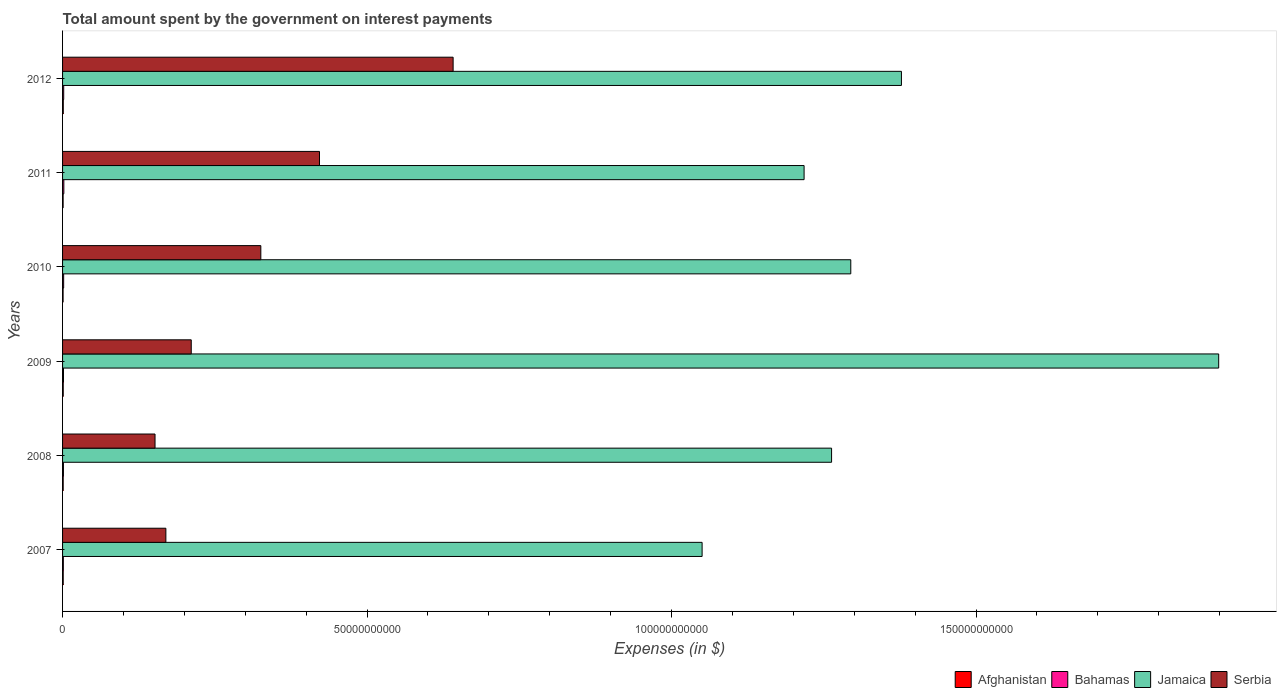How many groups of bars are there?
Make the answer very short. 6. Are the number of bars per tick equal to the number of legend labels?
Make the answer very short. Yes. How many bars are there on the 1st tick from the top?
Provide a short and direct response. 4. What is the label of the 3rd group of bars from the top?
Your response must be concise. 2010. In how many cases, is the number of bars for a given year not equal to the number of legend labels?
Ensure brevity in your answer.  0. What is the amount spent on interest payments by the government in Afghanistan in 2009?
Your answer should be compact. 1.09e+08. Across all years, what is the maximum amount spent on interest payments by the government in Afghanistan?
Your answer should be very brief. 1.18e+08. Across all years, what is the minimum amount spent on interest payments by the government in Serbia?
Your answer should be very brief. 1.52e+1. What is the total amount spent on interest payments by the government in Serbia in the graph?
Your answer should be compact. 1.92e+11. What is the difference between the amount spent on interest payments by the government in Bahamas in 2008 and that in 2009?
Your answer should be compact. -1.11e+07. What is the difference between the amount spent on interest payments by the government in Bahamas in 2011 and the amount spent on interest payments by the government in Afghanistan in 2007?
Offer a very short reply. 1.04e+08. What is the average amount spent on interest payments by the government in Afghanistan per year?
Give a very brief answer. 1.03e+08. In the year 2008, what is the difference between the amount spent on interest payments by the government in Jamaica and amount spent on interest payments by the government in Afghanistan?
Provide a succinct answer. 1.26e+11. What is the ratio of the amount spent on interest payments by the government in Serbia in 2008 to that in 2009?
Provide a short and direct response. 0.72. What is the difference between the highest and the second highest amount spent on interest payments by the government in Afghanistan?
Your answer should be very brief. 9.61e+06. What is the difference between the highest and the lowest amount spent on interest payments by the government in Jamaica?
Make the answer very short. 8.48e+1. What does the 4th bar from the top in 2007 represents?
Ensure brevity in your answer.  Afghanistan. What does the 2nd bar from the bottom in 2012 represents?
Offer a very short reply. Bahamas. Is it the case that in every year, the sum of the amount spent on interest payments by the government in Bahamas and amount spent on interest payments by the government in Serbia is greater than the amount spent on interest payments by the government in Afghanistan?
Keep it short and to the point. Yes. How many bars are there?
Ensure brevity in your answer.  24. Are all the bars in the graph horizontal?
Your response must be concise. Yes. What is the difference between two consecutive major ticks on the X-axis?
Make the answer very short. 5.00e+1. Are the values on the major ticks of X-axis written in scientific E-notation?
Your answer should be very brief. No. Does the graph contain any zero values?
Keep it short and to the point. No. Does the graph contain grids?
Keep it short and to the point. No. Where does the legend appear in the graph?
Keep it short and to the point. Bottom right. How are the legend labels stacked?
Offer a very short reply. Horizontal. What is the title of the graph?
Provide a short and direct response. Total amount spent by the government on interest payments. Does "Jordan" appear as one of the legend labels in the graph?
Provide a short and direct response. No. What is the label or title of the X-axis?
Provide a short and direct response. Expenses (in $). What is the label or title of the Y-axis?
Offer a terse response. Years. What is the Expenses (in $) in Afghanistan in 2007?
Your answer should be very brief. 1.07e+08. What is the Expenses (in $) in Bahamas in 2007?
Offer a very short reply. 1.27e+08. What is the Expenses (in $) in Jamaica in 2007?
Your answer should be compact. 1.05e+11. What is the Expenses (in $) of Serbia in 2007?
Offer a very short reply. 1.70e+1. What is the Expenses (in $) in Afghanistan in 2008?
Offer a very short reply. 1.03e+08. What is the Expenses (in $) of Bahamas in 2008?
Your answer should be compact. 1.43e+08. What is the Expenses (in $) of Jamaica in 2008?
Keep it short and to the point. 1.26e+11. What is the Expenses (in $) of Serbia in 2008?
Ensure brevity in your answer.  1.52e+1. What is the Expenses (in $) of Afghanistan in 2009?
Give a very brief answer. 1.09e+08. What is the Expenses (in $) of Bahamas in 2009?
Your answer should be very brief. 1.54e+08. What is the Expenses (in $) in Jamaica in 2009?
Your answer should be very brief. 1.90e+11. What is the Expenses (in $) of Serbia in 2009?
Ensure brevity in your answer.  2.11e+1. What is the Expenses (in $) in Afghanistan in 2010?
Ensure brevity in your answer.  8.66e+07. What is the Expenses (in $) of Bahamas in 2010?
Keep it short and to the point. 1.78e+08. What is the Expenses (in $) of Jamaica in 2010?
Keep it short and to the point. 1.29e+11. What is the Expenses (in $) in Serbia in 2010?
Your answer should be very brief. 3.26e+1. What is the Expenses (in $) in Afghanistan in 2011?
Provide a short and direct response. 9.20e+07. What is the Expenses (in $) in Bahamas in 2011?
Make the answer very short. 2.11e+08. What is the Expenses (in $) of Jamaica in 2011?
Provide a short and direct response. 1.22e+11. What is the Expenses (in $) of Serbia in 2011?
Provide a succinct answer. 4.22e+1. What is the Expenses (in $) in Afghanistan in 2012?
Ensure brevity in your answer.  1.18e+08. What is the Expenses (in $) in Bahamas in 2012?
Give a very brief answer. 1.86e+08. What is the Expenses (in $) of Jamaica in 2012?
Provide a succinct answer. 1.38e+11. What is the Expenses (in $) of Serbia in 2012?
Provide a short and direct response. 6.41e+1. Across all years, what is the maximum Expenses (in $) of Afghanistan?
Give a very brief answer. 1.18e+08. Across all years, what is the maximum Expenses (in $) in Bahamas?
Make the answer very short. 2.11e+08. Across all years, what is the maximum Expenses (in $) in Jamaica?
Offer a terse response. 1.90e+11. Across all years, what is the maximum Expenses (in $) of Serbia?
Ensure brevity in your answer.  6.41e+1. Across all years, what is the minimum Expenses (in $) of Afghanistan?
Provide a short and direct response. 8.66e+07. Across all years, what is the minimum Expenses (in $) in Bahamas?
Offer a very short reply. 1.27e+08. Across all years, what is the minimum Expenses (in $) of Jamaica?
Your response must be concise. 1.05e+11. Across all years, what is the minimum Expenses (in $) in Serbia?
Provide a short and direct response. 1.52e+1. What is the total Expenses (in $) of Afghanistan in the graph?
Offer a terse response. 6.15e+08. What is the total Expenses (in $) of Bahamas in the graph?
Ensure brevity in your answer.  1.00e+09. What is the total Expenses (in $) of Jamaica in the graph?
Your response must be concise. 8.10e+11. What is the total Expenses (in $) of Serbia in the graph?
Offer a very short reply. 1.92e+11. What is the difference between the Expenses (in $) of Afghanistan in 2007 and that in 2008?
Your answer should be compact. 3.63e+06. What is the difference between the Expenses (in $) of Bahamas in 2007 and that in 2008?
Offer a terse response. -1.60e+07. What is the difference between the Expenses (in $) in Jamaica in 2007 and that in 2008?
Your response must be concise. -2.13e+1. What is the difference between the Expenses (in $) in Serbia in 2007 and that in 2008?
Keep it short and to the point. 1.78e+09. What is the difference between the Expenses (in $) of Afghanistan in 2007 and that in 2009?
Your response must be concise. -1.90e+06. What is the difference between the Expenses (in $) of Bahamas in 2007 and that in 2009?
Your response must be concise. -2.71e+07. What is the difference between the Expenses (in $) of Jamaica in 2007 and that in 2009?
Provide a succinct answer. -8.48e+1. What is the difference between the Expenses (in $) in Serbia in 2007 and that in 2009?
Your response must be concise. -4.17e+09. What is the difference between the Expenses (in $) of Afghanistan in 2007 and that in 2010?
Offer a very short reply. 2.01e+07. What is the difference between the Expenses (in $) of Bahamas in 2007 and that in 2010?
Offer a very short reply. -5.13e+07. What is the difference between the Expenses (in $) of Jamaica in 2007 and that in 2010?
Offer a terse response. -2.44e+1. What is the difference between the Expenses (in $) of Serbia in 2007 and that in 2010?
Provide a short and direct response. -1.56e+1. What is the difference between the Expenses (in $) in Afghanistan in 2007 and that in 2011?
Provide a short and direct response. 1.47e+07. What is the difference between the Expenses (in $) in Bahamas in 2007 and that in 2011?
Your answer should be compact. -8.36e+07. What is the difference between the Expenses (in $) in Jamaica in 2007 and that in 2011?
Offer a very short reply. -1.67e+1. What is the difference between the Expenses (in $) of Serbia in 2007 and that in 2011?
Make the answer very short. -2.52e+1. What is the difference between the Expenses (in $) in Afghanistan in 2007 and that in 2012?
Make the answer very short. -1.15e+07. What is the difference between the Expenses (in $) in Bahamas in 2007 and that in 2012?
Provide a short and direct response. -5.89e+07. What is the difference between the Expenses (in $) of Jamaica in 2007 and that in 2012?
Your answer should be very brief. -3.27e+1. What is the difference between the Expenses (in $) in Serbia in 2007 and that in 2012?
Make the answer very short. -4.72e+1. What is the difference between the Expenses (in $) of Afghanistan in 2008 and that in 2009?
Provide a succinct answer. -5.54e+06. What is the difference between the Expenses (in $) in Bahamas in 2008 and that in 2009?
Make the answer very short. -1.11e+07. What is the difference between the Expenses (in $) in Jamaica in 2008 and that in 2009?
Your answer should be compact. -6.36e+1. What is the difference between the Expenses (in $) in Serbia in 2008 and that in 2009?
Offer a terse response. -5.95e+09. What is the difference between the Expenses (in $) of Afghanistan in 2008 and that in 2010?
Your response must be concise. 1.65e+07. What is the difference between the Expenses (in $) in Bahamas in 2008 and that in 2010?
Your response must be concise. -3.53e+07. What is the difference between the Expenses (in $) in Jamaica in 2008 and that in 2010?
Give a very brief answer. -3.15e+09. What is the difference between the Expenses (in $) of Serbia in 2008 and that in 2010?
Your response must be concise. -1.74e+1. What is the difference between the Expenses (in $) of Afghanistan in 2008 and that in 2011?
Give a very brief answer. 1.11e+07. What is the difference between the Expenses (in $) of Bahamas in 2008 and that in 2011?
Ensure brevity in your answer.  -6.76e+07. What is the difference between the Expenses (in $) of Jamaica in 2008 and that in 2011?
Offer a very short reply. 4.51e+09. What is the difference between the Expenses (in $) in Serbia in 2008 and that in 2011?
Your response must be concise. -2.70e+1. What is the difference between the Expenses (in $) of Afghanistan in 2008 and that in 2012?
Ensure brevity in your answer.  -1.51e+07. What is the difference between the Expenses (in $) in Bahamas in 2008 and that in 2012?
Provide a short and direct response. -4.30e+07. What is the difference between the Expenses (in $) in Jamaica in 2008 and that in 2012?
Your response must be concise. -1.15e+1. What is the difference between the Expenses (in $) of Serbia in 2008 and that in 2012?
Give a very brief answer. -4.89e+1. What is the difference between the Expenses (in $) of Afghanistan in 2009 and that in 2010?
Your answer should be very brief. 2.20e+07. What is the difference between the Expenses (in $) in Bahamas in 2009 and that in 2010?
Provide a succinct answer. -2.42e+07. What is the difference between the Expenses (in $) of Jamaica in 2009 and that in 2010?
Provide a short and direct response. 6.04e+1. What is the difference between the Expenses (in $) of Serbia in 2009 and that in 2010?
Provide a succinct answer. -1.14e+1. What is the difference between the Expenses (in $) in Afghanistan in 2009 and that in 2011?
Provide a succinct answer. 1.66e+07. What is the difference between the Expenses (in $) of Bahamas in 2009 and that in 2011?
Keep it short and to the point. -5.65e+07. What is the difference between the Expenses (in $) in Jamaica in 2009 and that in 2011?
Offer a very short reply. 6.81e+1. What is the difference between the Expenses (in $) in Serbia in 2009 and that in 2011?
Give a very brief answer. -2.11e+1. What is the difference between the Expenses (in $) in Afghanistan in 2009 and that in 2012?
Offer a very short reply. -9.61e+06. What is the difference between the Expenses (in $) in Bahamas in 2009 and that in 2012?
Provide a succinct answer. -3.19e+07. What is the difference between the Expenses (in $) of Jamaica in 2009 and that in 2012?
Give a very brief answer. 5.21e+1. What is the difference between the Expenses (in $) in Serbia in 2009 and that in 2012?
Ensure brevity in your answer.  -4.30e+1. What is the difference between the Expenses (in $) in Afghanistan in 2010 and that in 2011?
Offer a very short reply. -5.34e+06. What is the difference between the Expenses (in $) in Bahamas in 2010 and that in 2011?
Offer a terse response. -3.23e+07. What is the difference between the Expenses (in $) in Jamaica in 2010 and that in 2011?
Provide a succinct answer. 7.67e+09. What is the difference between the Expenses (in $) in Serbia in 2010 and that in 2011?
Provide a short and direct response. -9.63e+09. What is the difference between the Expenses (in $) in Afghanistan in 2010 and that in 2012?
Your answer should be very brief. -3.16e+07. What is the difference between the Expenses (in $) in Bahamas in 2010 and that in 2012?
Provide a succinct answer. -7.64e+06. What is the difference between the Expenses (in $) in Jamaica in 2010 and that in 2012?
Offer a very short reply. -8.32e+09. What is the difference between the Expenses (in $) of Serbia in 2010 and that in 2012?
Your answer should be very brief. -3.16e+1. What is the difference between the Expenses (in $) in Afghanistan in 2011 and that in 2012?
Ensure brevity in your answer.  -2.63e+07. What is the difference between the Expenses (in $) in Bahamas in 2011 and that in 2012?
Ensure brevity in your answer.  2.47e+07. What is the difference between the Expenses (in $) in Jamaica in 2011 and that in 2012?
Your answer should be very brief. -1.60e+1. What is the difference between the Expenses (in $) of Serbia in 2011 and that in 2012?
Provide a short and direct response. -2.19e+1. What is the difference between the Expenses (in $) in Afghanistan in 2007 and the Expenses (in $) in Bahamas in 2008?
Your answer should be compact. -3.64e+07. What is the difference between the Expenses (in $) of Afghanistan in 2007 and the Expenses (in $) of Jamaica in 2008?
Offer a very short reply. -1.26e+11. What is the difference between the Expenses (in $) in Afghanistan in 2007 and the Expenses (in $) in Serbia in 2008?
Ensure brevity in your answer.  -1.51e+1. What is the difference between the Expenses (in $) of Bahamas in 2007 and the Expenses (in $) of Jamaica in 2008?
Your response must be concise. -1.26e+11. What is the difference between the Expenses (in $) in Bahamas in 2007 and the Expenses (in $) in Serbia in 2008?
Your answer should be compact. -1.51e+1. What is the difference between the Expenses (in $) in Jamaica in 2007 and the Expenses (in $) in Serbia in 2008?
Your answer should be compact. 8.98e+1. What is the difference between the Expenses (in $) of Afghanistan in 2007 and the Expenses (in $) of Bahamas in 2009?
Keep it short and to the point. -4.75e+07. What is the difference between the Expenses (in $) of Afghanistan in 2007 and the Expenses (in $) of Jamaica in 2009?
Offer a terse response. -1.90e+11. What is the difference between the Expenses (in $) in Afghanistan in 2007 and the Expenses (in $) in Serbia in 2009?
Offer a very short reply. -2.10e+1. What is the difference between the Expenses (in $) of Bahamas in 2007 and the Expenses (in $) of Jamaica in 2009?
Offer a terse response. -1.90e+11. What is the difference between the Expenses (in $) of Bahamas in 2007 and the Expenses (in $) of Serbia in 2009?
Ensure brevity in your answer.  -2.10e+1. What is the difference between the Expenses (in $) in Jamaica in 2007 and the Expenses (in $) in Serbia in 2009?
Your answer should be compact. 8.39e+1. What is the difference between the Expenses (in $) in Afghanistan in 2007 and the Expenses (in $) in Bahamas in 2010?
Ensure brevity in your answer.  -7.17e+07. What is the difference between the Expenses (in $) of Afghanistan in 2007 and the Expenses (in $) of Jamaica in 2010?
Make the answer very short. -1.29e+11. What is the difference between the Expenses (in $) in Afghanistan in 2007 and the Expenses (in $) in Serbia in 2010?
Provide a short and direct response. -3.25e+1. What is the difference between the Expenses (in $) of Bahamas in 2007 and the Expenses (in $) of Jamaica in 2010?
Your answer should be compact. -1.29e+11. What is the difference between the Expenses (in $) in Bahamas in 2007 and the Expenses (in $) in Serbia in 2010?
Your answer should be very brief. -3.24e+1. What is the difference between the Expenses (in $) of Jamaica in 2007 and the Expenses (in $) of Serbia in 2010?
Make the answer very short. 7.25e+1. What is the difference between the Expenses (in $) of Afghanistan in 2007 and the Expenses (in $) of Bahamas in 2011?
Ensure brevity in your answer.  -1.04e+08. What is the difference between the Expenses (in $) of Afghanistan in 2007 and the Expenses (in $) of Jamaica in 2011?
Offer a terse response. -1.22e+11. What is the difference between the Expenses (in $) in Afghanistan in 2007 and the Expenses (in $) in Serbia in 2011?
Give a very brief answer. -4.21e+1. What is the difference between the Expenses (in $) of Bahamas in 2007 and the Expenses (in $) of Jamaica in 2011?
Ensure brevity in your answer.  -1.22e+11. What is the difference between the Expenses (in $) in Bahamas in 2007 and the Expenses (in $) in Serbia in 2011?
Offer a terse response. -4.21e+1. What is the difference between the Expenses (in $) of Jamaica in 2007 and the Expenses (in $) of Serbia in 2011?
Keep it short and to the point. 6.28e+1. What is the difference between the Expenses (in $) of Afghanistan in 2007 and the Expenses (in $) of Bahamas in 2012?
Provide a succinct answer. -7.94e+07. What is the difference between the Expenses (in $) in Afghanistan in 2007 and the Expenses (in $) in Jamaica in 2012?
Keep it short and to the point. -1.38e+11. What is the difference between the Expenses (in $) in Afghanistan in 2007 and the Expenses (in $) in Serbia in 2012?
Keep it short and to the point. -6.40e+1. What is the difference between the Expenses (in $) in Bahamas in 2007 and the Expenses (in $) in Jamaica in 2012?
Provide a short and direct response. -1.38e+11. What is the difference between the Expenses (in $) of Bahamas in 2007 and the Expenses (in $) of Serbia in 2012?
Offer a terse response. -6.40e+1. What is the difference between the Expenses (in $) in Jamaica in 2007 and the Expenses (in $) in Serbia in 2012?
Offer a terse response. 4.09e+1. What is the difference between the Expenses (in $) of Afghanistan in 2008 and the Expenses (in $) of Bahamas in 2009?
Provide a succinct answer. -5.11e+07. What is the difference between the Expenses (in $) of Afghanistan in 2008 and the Expenses (in $) of Jamaica in 2009?
Give a very brief answer. -1.90e+11. What is the difference between the Expenses (in $) in Afghanistan in 2008 and the Expenses (in $) in Serbia in 2009?
Provide a succinct answer. -2.10e+1. What is the difference between the Expenses (in $) in Bahamas in 2008 and the Expenses (in $) in Jamaica in 2009?
Ensure brevity in your answer.  -1.90e+11. What is the difference between the Expenses (in $) in Bahamas in 2008 and the Expenses (in $) in Serbia in 2009?
Your answer should be compact. -2.10e+1. What is the difference between the Expenses (in $) of Jamaica in 2008 and the Expenses (in $) of Serbia in 2009?
Your answer should be compact. 1.05e+11. What is the difference between the Expenses (in $) in Afghanistan in 2008 and the Expenses (in $) in Bahamas in 2010?
Offer a very short reply. -7.54e+07. What is the difference between the Expenses (in $) of Afghanistan in 2008 and the Expenses (in $) of Jamaica in 2010?
Offer a very short reply. -1.29e+11. What is the difference between the Expenses (in $) of Afghanistan in 2008 and the Expenses (in $) of Serbia in 2010?
Ensure brevity in your answer.  -3.25e+1. What is the difference between the Expenses (in $) in Bahamas in 2008 and the Expenses (in $) in Jamaica in 2010?
Make the answer very short. -1.29e+11. What is the difference between the Expenses (in $) of Bahamas in 2008 and the Expenses (in $) of Serbia in 2010?
Give a very brief answer. -3.24e+1. What is the difference between the Expenses (in $) of Jamaica in 2008 and the Expenses (in $) of Serbia in 2010?
Your answer should be compact. 9.37e+1. What is the difference between the Expenses (in $) of Afghanistan in 2008 and the Expenses (in $) of Bahamas in 2011?
Ensure brevity in your answer.  -1.08e+08. What is the difference between the Expenses (in $) in Afghanistan in 2008 and the Expenses (in $) in Jamaica in 2011?
Ensure brevity in your answer.  -1.22e+11. What is the difference between the Expenses (in $) of Afghanistan in 2008 and the Expenses (in $) of Serbia in 2011?
Offer a terse response. -4.21e+1. What is the difference between the Expenses (in $) in Bahamas in 2008 and the Expenses (in $) in Jamaica in 2011?
Your answer should be compact. -1.22e+11. What is the difference between the Expenses (in $) of Bahamas in 2008 and the Expenses (in $) of Serbia in 2011?
Offer a very short reply. -4.20e+1. What is the difference between the Expenses (in $) in Jamaica in 2008 and the Expenses (in $) in Serbia in 2011?
Your answer should be very brief. 8.41e+1. What is the difference between the Expenses (in $) of Afghanistan in 2008 and the Expenses (in $) of Bahamas in 2012?
Offer a very short reply. -8.30e+07. What is the difference between the Expenses (in $) of Afghanistan in 2008 and the Expenses (in $) of Jamaica in 2012?
Offer a very short reply. -1.38e+11. What is the difference between the Expenses (in $) of Afghanistan in 2008 and the Expenses (in $) of Serbia in 2012?
Ensure brevity in your answer.  -6.40e+1. What is the difference between the Expenses (in $) in Bahamas in 2008 and the Expenses (in $) in Jamaica in 2012?
Provide a short and direct response. -1.38e+11. What is the difference between the Expenses (in $) of Bahamas in 2008 and the Expenses (in $) of Serbia in 2012?
Your answer should be compact. -6.40e+1. What is the difference between the Expenses (in $) of Jamaica in 2008 and the Expenses (in $) of Serbia in 2012?
Your answer should be very brief. 6.21e+1. What is the difference between the Expenses (in $) of Afghanistan in 2009 and the Expenses (in $) of Bahamas in 2010?
Provide a short and direct response. -6.98e+07. What is the difference between the Expenses (in $) in Afghanistan in 2009 and the Expenses (in $) in Jamaica in 2010?
Provide a succinct answer. -1.29e+11. What is the difference between the Expenses (in $) in Afghanistan in 2009 and the Expenses (in $) in Serbia in 2010?
Make the answer very short. -3.25e+1. What is the difference between the Expenses (in $) of Bahamas in 2009 and the Expenses (in $) of Jamaica in 2010?
Provide a succinct answer. -1.29e+11. What is the difference between the Expenses (in $) of Bahamas in 2009 and the Expenses (in $) of Serbia in 2010?
Provide a succinct answer. -3.24e+1. What is the difference between the Expenses (in $) in Jamaica in 2009 and the Expenses (in $) in Serbia in 2010?
Provide a short and direct response. 1.57e+11. What is the difference between the Expenses (in $) in Afghanistan in 2009 and the Expenses (in $) in Bahamas in 2011?
Ensure brevity in your answer.  -1.02e+08. What is the difference between the Expenses (in $) of Afghanistan in 2009 and the Expenses (in $) of Jamaica in 2011?
Your answer should be very brief. -1.22e+11. What is the difference between the Expenses (in $) of Afghanistan in 2009 and the Expenses (in $) of Serbia in 2011?
Keep it short and to the point. -4.21e+1. What is the difference between the Expenses (in $) of Bahamas in 2009 and the Expenses (in $) of Jamaica in 2011?
Provide a short and direct response. -1.22e+11. What is the difference between the Expenses (in $) in Bahamas in 2009 and the Expenses (in $) in Serbia in 2011?
Your answer should be very brief. -4.20e+1. What is the difference between the Expenses (in $) of Jamaica in 2009 and the Expenses (in $) of Serbia in 2011?
Offer a terse response. 1.48e+11. What is the difference between the Expenses (in $) in Afghanistan in 2009 and the Expenses (in $) in Bahamas in 2012?
Provide a short and direct response. -7.75e+07. What is the difference between the Expenses (in $) in Afghanistan in 2009 and the Expenses (in $) in Jamaica in 2012?
Your answer should be compact. -1.38e+11. What is the difference between the Expenses (in $) of Afghanistan in 2009 and the Expenses (in $) of Serbia in 2012?
Offer a terse response. -6.40e+1. What is the difference between the Expenses (in $) in Bahamas in 2009 and the Expenses (in $) in Jamaica in 2012?
Your response must be concise. -1.38e+11. What is the difference between the Expenses (in $) of Bahamas in 2009 and the Expenses (in $) of Serbia in 2012?
Make the answer very short. -6.40e+1. What is the difference between the Expenses (in $) of Jamaica in 2009 and the Expenses (in $) of Serbia in 2012?
Your answer should be compact. 1.26e+11. What is the difference between the Expenses (in $) of Afghanistan in 2010 and the Expenses (in $) of Bahamas in 2011?
Provide a succinct answer. -1.24e+08. What is the difference between the Expenses (in $) in Afghanistan in 2010 and the Expenses (in $) in Jamaica in 2011?
Keep it short and to the point. -1.22e+11. What is the difference between the Expenses (in $) in Afghanistan in 2010 and the Expenses (in $) in Serbia in 2011?
Provide a succinct answer. -4.21e+1. What is the difference between the Expenses (in $) of Bahamas in 2010 and the Expenses (in $) of Jamaica in 2011?
Offer a terse response. -1.22e+11. What is the difference between the Expenses (in $) of Bahamas in 2010 and the Expenses (in $) of Serbia in 2011?
Offer a terse response. -4.20e+1. What is the difference between the Expenses (in $) in Jamaica in 2010 and the Expenses (in $) in Serbia in 2011?
Your response must be concise. 8.72e+1. What is the difference between the Expenses (in $) of Afghanistan in 2010 and the Expenses (in $) of Bahamas in 2012?
Provide a succinct answer. -9.95e+07. What is the difference between the Expenses (in $) of Afghanistan in 2010 and the Expenses (in $) of Jamaica in 2012?
Offer a very short reply. -1.38e+11. What is the difference between the Expenses (in $) in Afghanistan in 2010 and the Expenses (in $) in Serbia in 2012?
Ensure brevity in your answer.  -6.40e+1. What is the difference between the Expenses (in $) in Bahamas in 2010 and the Expenses (in $) in Jamaica in 2012?
Offer a terse response. -1.38e+11. What is the difference between the Expenses (in $) in Bahamas in 2010 and the Expenses (in $) in Serbia in 2012?
Keep it short and to the point. -6.40e+1. What is the difference between the Expenses (in $) in Jamaica in 2010 and the Expenses (in $) in Serbia in 2012?
Your answer should be compact. 6.53e+1. What is the difference between the Expenses (in $) of Afghanistan in 2011 and the Expenses (in $) of Bahamas in 2012?
Your answer should be compact. -9.41e+07. What is the difference between the Expenses (in $) of Afghanistan in 2011 and the Expenses (in $) of Jamaica in 2012?
Make the answer very short. -1.38e+11. What is the difference between the Expenses (in $) of Afghanistan in 2011 and the Expenses (in $) of Serbia in 2012?
Keep it short and to the point. -6.40e+1. What is the difference between the Expenses (in $) in Bahamas in 2011 and the Expenses (in $) in Jamaica in 2012?
Your response must be concise. -1.38e+11. What is the difference between the Expenses (in $) of Bahamas in 2011 and the Expenses (in $) of Serbia in 2012?
Provide a succinct answer. -6.39e+1. What is the difference between the Expenses (in $) of Jamaica in 2011 and the Expenses (in $) of Serbia in 2012?
Make the answer very short. 5.76e+1. What is the average Expenses (in $) of Afghanistan per year?
Offer a very short reply. 1.03e+08. What is the average Expenses (in $) of Bahamas per year?
Provide a short and direct response. 1.67e+08. What is the average Expenses (in $) of Jamaica per year?
Ensure brevity in your answer.  1.35e+11. What is the average Expenses (in $) of Serbia per year?
Ensure brevity in your answer.  3.20e+1. In the year 2007, what is the difference between the Expenses (in $) of Afghanistan and Expenses (in $) of Bahamas?
Make the answer very short. -2.04e+07. In the year 2007, what is the difference between the Expenses (in $) in Afghanistan and Expenses (in $) in Jamaica?
Make the answer very short. -1.05e+11. In the year 2007, what is the difference between the Expenses (in $) of Afghanistan and Expenses (in $) of Serbia?
Offer a terse response. -1.69e+1. In the year 2007, what is the difference between the Expenses (in $) in Bahamas and Expenses (in $) in Jamaica?
Give a very brief answer. -1.05e+11. In the year 2007, what is the difference between the Expenses (in $) in Bahamas and Expenses (in $) in Serbia?
Your answer should be compact. -1.68e+1. In the year 2007, what is the difference between the Expenses (in $) of Jamaica and Expenses (in $) of Serbia?
Provide a succinct answer. 8.81e+1. In the year 2008, what is the difference between the Expenses (in $) of Afghanistan and Expenses (in $) of Bahamas?
Your response must be concise. -4.00e+07. In the year 2008, what is the difference between the Expenses (in $) of Afghanistan and Expenses (in $) of Jamaica?
Ensure brevity in your answer.  -1.26e+11. In the year 2008, what is the difference between the Expenses (in $) in Afghanistan and Expenses (in $) in Serbia?
Provide a short and direct response. -1.51e+1. In the year 2008, what is the difference between the Expenses (in $) of Bahamas and Expenses (in $) of Jamaica?
Your response must be concise. -1.26e+11. In the year 2008, what is the difference between the Expenses (in $) in Bahamas and Expenses (in $) in Serbia?
Your answer should be very brief. -1.50e+1. In the year 2008, what is the difference between the Expenses (in $) of Jamaica and Expenses (in $) of Serbia?
Your answer should be very brief. 1.11e+11. In the year 2009, what is the difference between the Expenses (in $) of Afghanistan and Expenses (in $) of Bahamas?
Provide a succinct answer. -4.56e+07. In the year 2009, what is the difference between the Expenses (in $) in Afghanistan and Expenses (in $) in Jamaica?
Your answer should be very brief. -1.90e+11. In the year 2009, what is the difference between the Expenses (in $) of Afghanistan and Expenses (in $) of Serbia?
Give a very brief answer. -2.10e+1. In the year 2009, what is the difference between the Expenses (in $) of Bahamas and Expenses (in $) of Jamaica?
Offer a terse response. -1.90e+11. In the year 2009, what is the difference between the Expenses (in $) of Bahamas and Expenses (in $) of Serbia?
Ensure brevity in your answer.  -2.10e+1. In the year 2009, what is the difference between the Expenses (in $) in Jamaica and Expenses (in $) in Serbia?
Offer a very short reply. 1.69e+11. In the year 2010, what is the difference between the Expenses (in $) in Afghanistan and Expenses (in $) in Bahamas?
Your answer should be compact. -9.18e+07. In the year 2010, what is the difference between the Expenses (in $) of Afghanistan and Expenses (in $) of Jamaica?
Keep it short and to the point. -1.29e+11. In the year 2010, what is the difference between the Expenses (in $) of Afghanistan and Expenses (in $) of Serbia?
Provide a succinct answer. -3.25e+1. In the year 2010, what is the difference between the Expenses (in $) in Bahamas and Expenses (in $) in Jamaica?
Your answer should be very brief. -1.29e+11. In the year 2010, what is the difference between the Expenses (in $) in Bahamas and Expenses (in $) in Serbia?
Keep it short and to the point. -3.24e+1. In the year 2010, what is the difference between the Expenses (in $) of Jamaica and Expenses (in $) of Serbia?
Make the answer very short. 9.69e+1. In the year 2011, what is the difference between the Expenses (in $) of Afghanistan and Expenses (in $) of Bahamas?
Provide a succinct answer. -1.19e+08. In the year 2011, what is the difference between the Expenses (in $) in Afghanistan and Expenses (in $) in Jamaica?
Your answer should be compact. -1.22e+11. In the year 2011, what is the difference between the Expenses (in $) in Afghanistan and Expenses (in $) in Serbia?
Give a very brief answer. -4.21e+1. In the year 2011, what is the difference between the Expenses (in $) of Bahamas and Expenses (in $) of Jamaica?
Ensure brevity in your answer.  -1.22e+11. In the year 2011, what is the difference between the Expenses (in $) in Bahamas and Expenses (in $) in Serbia?
Give a very brief answer. -4.20e+1. In the year 2011, what is the difference between the Expenses (in $) in Jamaica and Expenses (in $) in Serbia?
Ensure brevity in your answer.  7.96e+1. In the year 2012, what is the difference between the Expenses (in $) in Afghanistan and Expenses (in $) in Bahamas?
Provide a succinct answer. -6.79e+07. In the year 2012, what is the difference between the Expenses (in $) of Afghanistan and Expenses (in $) of Jamaica?
Provide a short and direct response. -1.38e+11. In the year 2012, what is the difference between the Expenses (in $) in Afghanistan and Expenses (in $) in Serbia?
Ensure brevity in your answer.  -6.40e+1. In the year 2012, what is the difference between the Expenses (in $) of Bahamas and Expenses (in $) of Jamaica?
Provide a succinct answer. -1.38e+11. In the year 2012, what is the difference between the Expenses (in $) in Bahamas and Expenses (in $) in Serbia?
Provide a succinct answer. -6.39e+1. In the year 2012, what is the difference between the Expenses (in $) in Jamaica and Expenses (in $) in Serbia?
Keep it short and to the point. 7.36e+1. What is the ratio of the Expenses (in $) of Afghanistan in 2007 to that in 2008?
Keep it short and to the point. 1.04. What is the ratio of the Expenses (in $) of Bahamas in 2007 to that in 2008?
Your answer should be compact. 0.89. What is the ratio of the Expenses (in $) of Jamaica in 2007 to that in 2008?
Your answer should be compact. 0.83. What is the ratio of the Expenses (in $) of Serbia in 2007 to that in 2008?
Ensure brevity in your answer.  1.12. What is the ratio of the Expenses (in $) in Afghanistan in 2007 to that in 2009?
Give a very brief answer. 0.98. What is the ratio of the Expenses (in $) in Bahamas in 2007 to that in 2009?
Offer a very short reply. 0.82. What is the ratio of the Expenses (in $) in Jamaica in 2007 to that in 2009?
Offer a very short reply. 0.55. What is the ratio of the Expenses (in $) in Serbia in 2007 to that in 2009?
Offer a terse response. 0.8. What is the ratio of the Expenses (in $) of Afghanistan in 2007 to that in 2010?
Give a very brief answer. 1.23. What is the ratio of the Expenses (in $) of Bahamas in 2007 to that in 2010?
Ensure brevity in your answer.  0.71. What is the ratio of the Expenses (in $) of Jamaica in 2007 to that in 2010?
Provide a succinct answer. 0.81. What is the ratio of the Expenses (in $) of Serbia in 2007 to that in 2010?
Your answer should be compact. 0.52. What is the ratio of the Expenses (in $) of Afghanistan in 2007 to that in 2011?
Offer a very short reply. 1.16. What is the ratio of the Expenses (in $) in Bahamas in 2007 to that in 2011?
Keep it short and to the point. 0.6. What is the ratio of the Expenses (in $) in Jamaica in 2007 to that in 2011?
Your response must be concise. 0.86. What is the ratio of the Expenses (in $) of Serbia in 2007 to that in 2011?
Keep it short and to the point. 0.4. What is the ratio of the Expenses (in $) of Afghanistan in 2007 to that in 2012?
Provide a short and direct response. 0.9. What is the ratio of the Expenses (in $) in Bahamas in 2007 to that in 2012?
Give a very brief answer. 0.68. What is the ratio of the Expenses (in $) in Jamaica in 2007 to that in 2012?
Make the answer very short. 0.76. What is the ratio of the Expenses (in $) in Serbia in 2007 to that in 2012?
Your response must be concise. 0.26. What is the ratio of the Expenses (in $) of Afghanistan in 2008 to that in 2009?
Give a very brief answer. 0.95. What is the ratio of the Expenses (in $) of Bahamas in 2008 to that in 2009?
Provide a short and direct response. 0.93. What is the ratio of the Expenses (in $) in Jamaica in 2008 to that in 2009?
Offer a very short reply. 0.67. What is the ratio of the Expenses (in $) in Serbia in 2008 to that in 2009?
Your response must be concise. 0.72. What is the ratio of the Expenses (in $) in Afghanistan in 2008 to that in 2010?
Give a very brief answer. 1.19. What is the ratio of the Expenses (in $) of Bahamas in 2008 to that in 2010?
Make the answer very short. 0.8. What is the ratio of the Expenses (in $) of Jamaica in 2008 to that in 2010?
Keep it short and to the point. 0.98. What is the ratio of the Expenses (in $) in Serbia in 2008 to that in 2010?
Your answer should be compact. 0.47. What is the ratio of the Expenses (in $) in Afghanistan in 2008 to that in 2011?
Offer a terse response. 1.12. What is the ratio of the Expenses (in $) in Bahamas in 2008 to that in 2011?
Your answer should be very brief. 0.68. What is the ratio of the Expenses (in $) in Jamaica in 2008 to that in 2011?
Keep it short and to the point. 1.04. What is the ratio of the Expenses (in $) of Serbia in 2008 to that in 2011?
Your response must be concise. 0.36. What is the ratio of the Expenses (in $) in Afghanistan in 2008 to that in 2012?
Give a very brief answer. 0.87. What is the ratio of the Expenses (in $) in Bahamas in 2008 to that in 2012?
Make the answer very short. 0.77. What is the ratio of the Expenses (in $) of Jamaica in 2008 to that in 2012?
Ensure brevity in your answer.  0.92. What is the ratio of the Expenses (in $) in Serbia in 2008 to that in 2012?
Offer a terse response. 0.24. What is the ratio of the Expenses (in $) of Afghanistan in 2009 to that in 2010?
Provide a succinct answer. 1.25. What is the ratio of the Expenses (in $) of Bahamas in 2009 to that in 2010?
Give a very brief answer. 0.86. What is the ratio of the Expenses (in $) in Jamaica in 2009 to that in 2010?
Keep it short and to the point. 1.47. What is the ratio of the Expenses (in $) of Serbia in 2009 to that in 2010?
Ensure brevity in your answer.  0.65. What is the ratio of the Expenses (in $) of Afghanistan in 2009 to that in 2011?
Offer a terse response. 1.18. What is the ratio of the Expenses (in $) of Bahamas in 2009 to that in 2011?
Provide a short and direct response. 0.73. What is the ratio of the Expenses (in $) in Jamaica in 2009 to that in 2011?
Your response must be concise. 1.56. What is the ratio of the Expenses (in $) of Serbia in 2009 to that in 2011?
Provide a succinct answer. 0.5. What is the ratio of the Expenses (in $) of Afghanistan in 2009 to that in 2012?
Offer a very short reply. 0.92. What is the ratio of the Expenses (in $) of Bahamas in 2009 to that in 2012?
Offer a terse response. 0.83. What is the ratio of the Expenses (in $) in Jamaica in 2009 to that in 2012?
Provide a succinct answer. 1.38. What is the ratio of the Expenses (in $) in Serbia in 2009 to that in 2012?
Your response must be concise. 0.33. What is the ratio of the Expenses (in $) of Afghanistan in 2010 to that in 2011?
Your answer should be very brief. 0.94. What is the ratio of the Expenses (in $) in Bahamas in 2010 to that in 2011?
Make the answer very short. 0.85. What is the ratio of the Expenses (in $) of Jamaica in 2010 to that in 2011?
Your answer should be very brief. 1.06. What is the ratio of the Expenses (in $) in Serbia in 2010 to that in 2011?
Ensure brevity in your answer.  0.77. What is the ratio of the Expenses (in $) in Afghanistan in 2010 to that in 2012?
Offer a very short reply. 0.73. What is the ratio of the Expenses (in $) in Jamaica in 2010 to that in 2012?
Ensure brevity in your answer.  0.94. What is the ratio of the Expenses (in $) of Serbia in 2010 to that in 2012?
Ensure brevity in your answer.  0.51. What is the ratio of the Expenses (in $) of Afghanistan in 2011 to that in 2012?
Make the answer very short. 0.78. What is the ratio of the Expenses (in $) in Bahamas in 2011 to that in 2012?
Provide a succinct answer. 1.13. What is the ratio of the Expenses (in $) in Jamaica in 2011 to that in 2012?
Offer a very short reply. 0.88. What is the ratio of the Expenses (in $) in Serbia in 2011 to that in 2012?
Give a very brief answer. 0.66. What is the difference between the highest and the second highest Expenses (in $) of Afghanistan?
Offer a very short reply. 9.61e+06. What is the difference between the highest and the second highest Expenses (in $) in Bahamas?
Keep it short and to the point. 2.47e+07. What is the difference between the highest and the second highest Expenses (in $) of Jamaica?
Ensure brevity in your answer.  5.21e+1. What is the difference between the highest and the second highest Expenses (in $) of Serbia?
Keep it short and to the point. 2.19e+1. What is the difference between the highest and the lowest Expenses (in $) of Afghanistan?
Provide a succinct answer. 3.16e+07. What is the difference between the highest and the lowest Expenses (in $) of Bahamas?
Keep it short and to the point. 8.36e+07. What is the difference between the highest and the lowest Expenses (in $) in Jamaica?
Give a very brief answer. 8.48e+1. What is the difference between the highest and the lowest Expenses (in $) in Serbia?
Your answer should be very brief. 4.89e+1. 